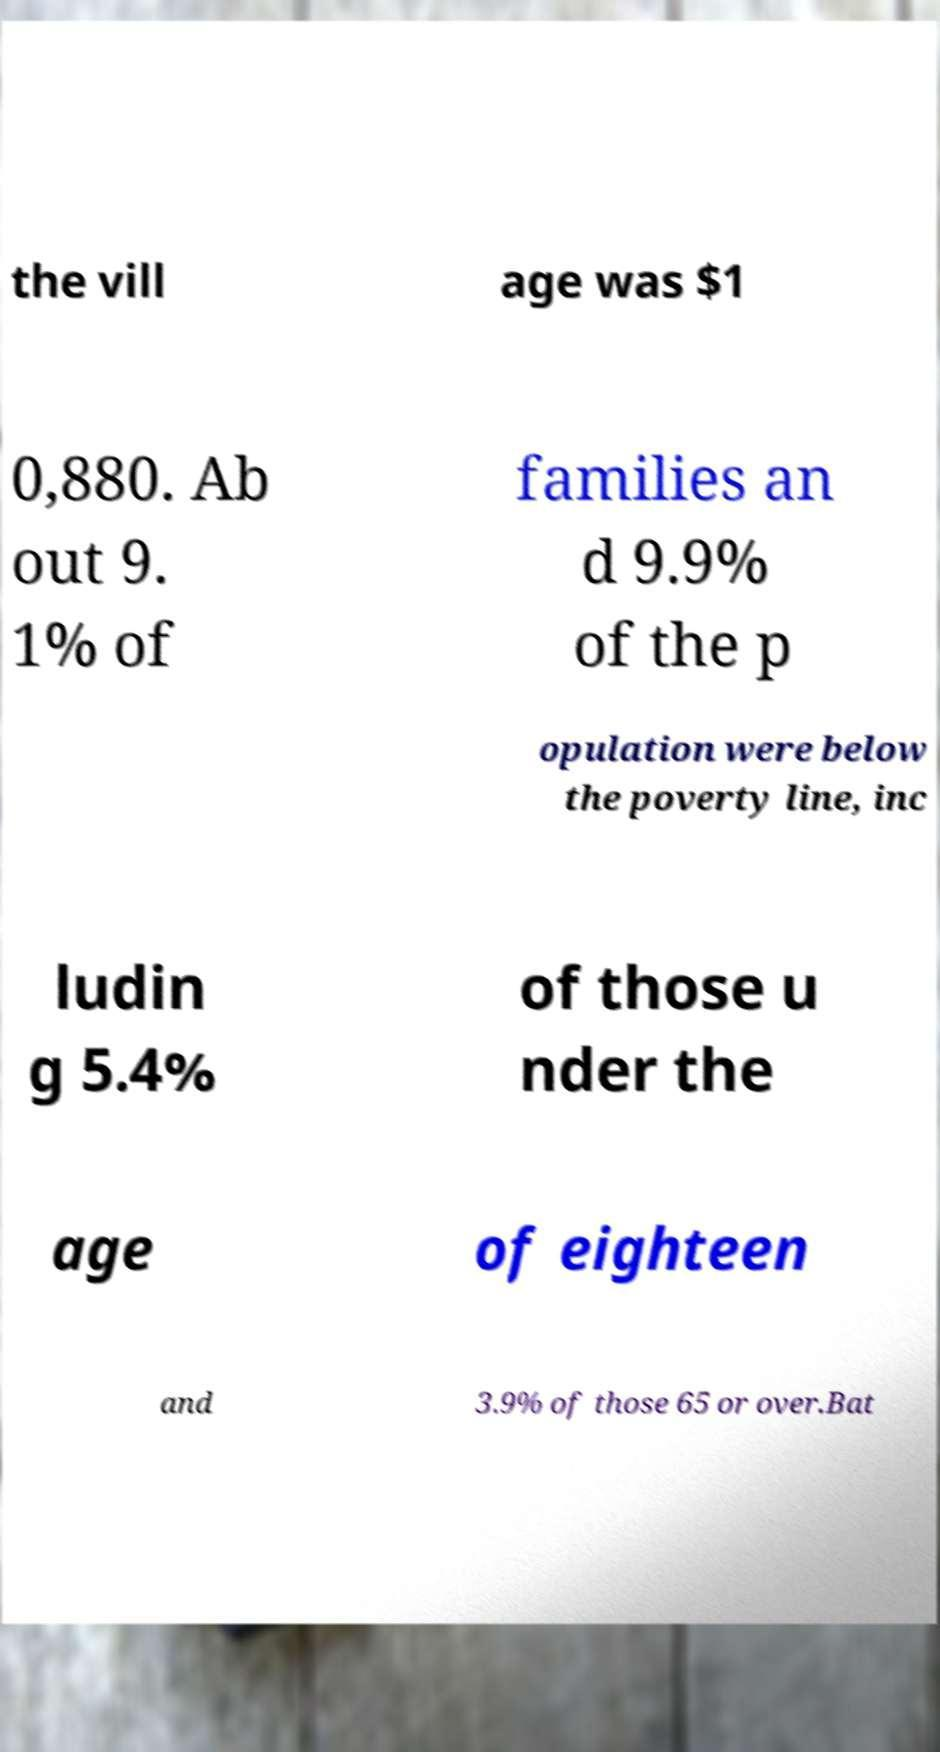Can you accurately transcribe the text from the provided image for me? the vill age was $1 0,880. Ab out 9. 1% of families an d 9.9% of the p opulation were below the poverty line, inc ludin g 5.4% of those u nder the age of eighteen and 3.9% of those 65 or over.Bat 